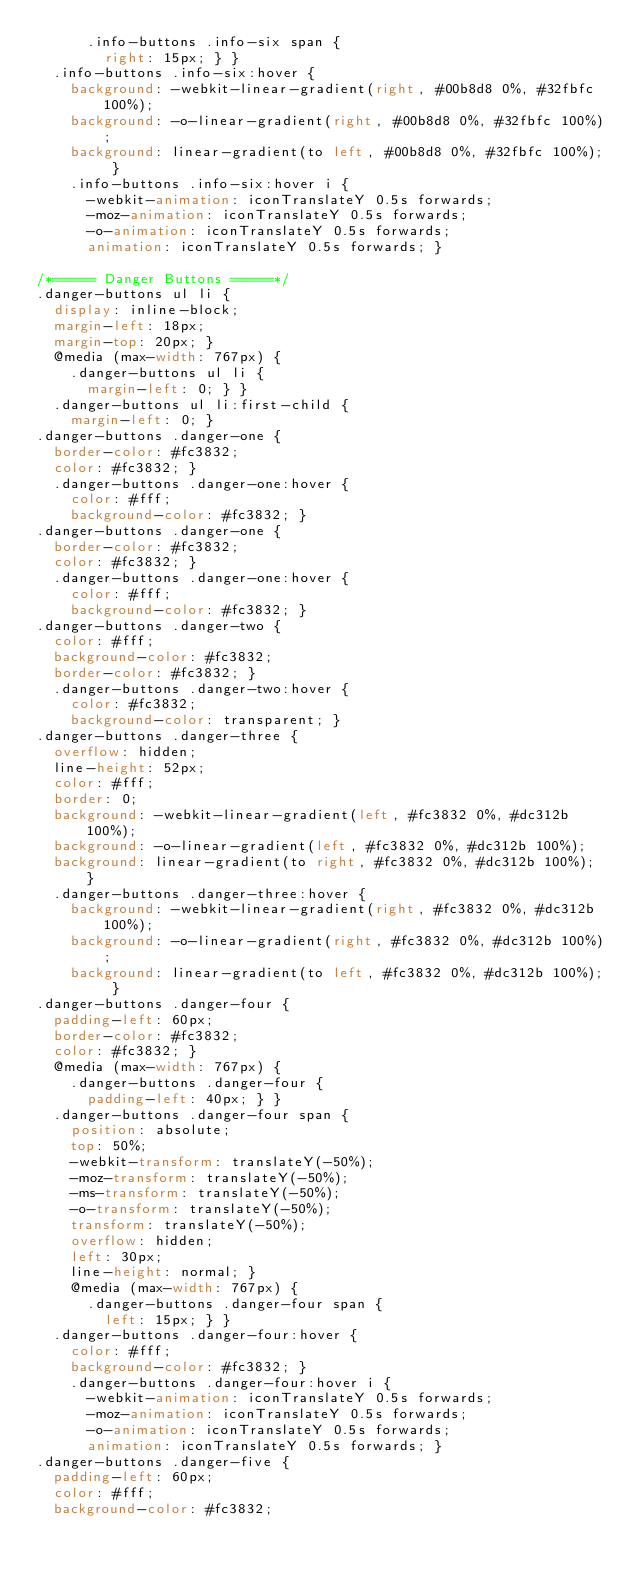Convert code to text. <code><loc_0><loc_0><loc_500><loc_500><_CSS_>      .info-buttons .info-six span {
        right: 15px; } }
  .info-buttons .info-six:hover {
    background: -webkit-linear-gradient(right, #00b8d8 0%, #32fbfc 100%);
    background: -o-linear-gradient(right, #00b8d8 0%, #32fbfc 100%);
    background: linear-gradient(to left, #00b8d8 0%, #32fbfc 100%); }
    .info-buttons .info-six:hover i {
      -webkit-animation: iconTranslateY 0.5s forwards;
      -moz-animation: iconTranslateY 0.5s forwards;
      -o-animation: iconTranslateY 0.5s forwards;
      animation: iconTranslateY 0.5s forwards; }

/*===== Danger Buttons =====*/
.danger-buttons ul li {
  display: inline-block;
  margin-left: 18px;
  margin-top: 20px; }
  @media (max-width: 767px) {
    .danger-buttons ul li {
      margin-left: 0; } }
  .danger-buttons ul li:first-child {
    margin-left: 0; }
.danger-buttons .danger-one {
  border-color: #fc3832;
  color: #fc3832; }
  .danger-buttons .danger-one:hover {
    color: #fff;
    background-color: #fc3832; }
.danger-buttons .danger-one {
  border-color: #fc3832;
  color: #fc3832; }
  .danger-buttons .danger-one:hover {
    color: #fff;
    background-color: #fc3832; }
.danger-buttons .danger-two {
  color: #fff;
  background-color: #fc3832;
  border-color: #fc3832; }
  .danger-buttons .danger-two:hover {
    color: #fc3832;
    background-color: transparent; }
.danger-buttons .danger-three {
  overflow: hidden;
  line-height: 52px;
  color: #fff;
  border: 0;
  background: -webkit-linear-gradient(left, #fc3832 0%, #dc312b 100%);
  background: -o-linear-gradient(left, #fc3832 0%, #dc312b 100%);
  background: linear-gradient(to right, #fc3832 0%, #dc312b 100%); }
  .danger-buttons .danger-three:hover {
    background: -webkit-linear-gradient(right, #fc3832 0%, #dc312b 100%);
    background: -o-linear-gradient(right, #fc3832 0%, #dc312b 100%);
    background: linear-gradient(to left, #fc3832 0%, #dc312b 100%); }
.danger-buttons .danger-four {
  padding-left: 60px;
  border-color: #fc3832;
  color: #fc3832; }
  @media (max-width: 767px) {
    .danger-buttons .danger-four {
      padding-left: 40px; } }
  .danger-buttons .danger-four span {
    position: absolute;
    top: 50%;
    -webkit-transform: translateY(-50%);
    -moz-transform: translateY(-50%);
    -ms-transform: translateY(-50%);
    -o-transform: translateY(-50%);
    transform: translateY(-50%);
    overflow: hidden;
    left: 30px;
    line-height: normal; }
    @media (max-width: 767px) {
      .danger-buttons .danger-four span {
        left: 15px; } }
  .danger-buttons .danger-four:hover {
    color: #fff;
    background-color: #fc3832; }
    .danger-buttons .danger-four:hover i {
      -webkit-animation: iconTranslateY 0.5s forwards;
      -moz-animation: iconTranslateY 0.5s forwards;
      -o-animation: iconTranslateY 0.5s forwards;
      animation: iconTranslateY 0.5s forwards; }
.danger-buttons .danger-five {
  padding-left: 60px;
  color: #fff;
  background-color: #fc3832;</code> 